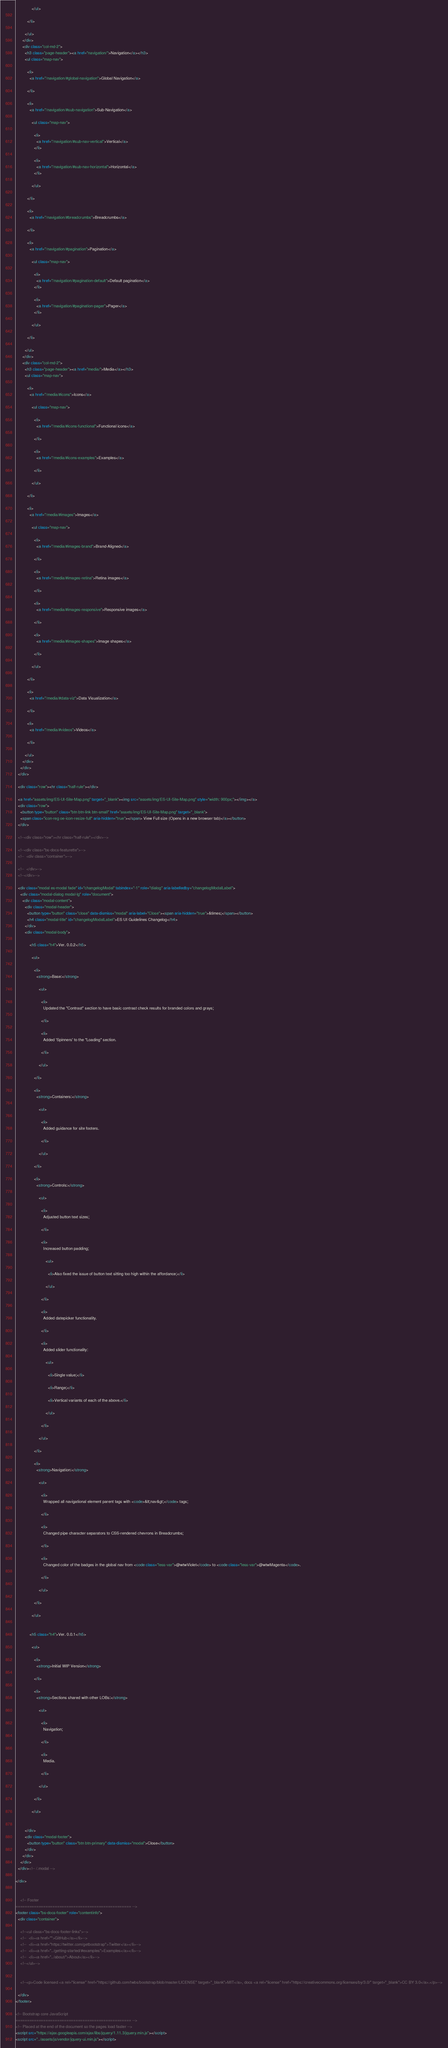<code> <loc_0><loc_0><loc_500><loc_500><_HTML_>              </ul>
            
          </li>
        
        </ul>  
      </div>
      <div class="col-md-2">
        <h3 class="page-header"><a href="navigation/">Navigation</a></h3>
        <ul class="map-nav">
        
          <li>
            <a href="/navigation/#global-navigation">Global Navigation</a>
            
          </li>
        
          <li>
            <a href="/navigation/#sub-navigation">Sub-Navigation</a>
            
              <ul class="map-nav">
                
                <li>
                  <a href="/navigation/#sub-nav-vertical">Vertical</a>
                </li>
                
                <li>
                  <a href="/navigation/#sub-nav-horizontal">Horizontal</a>
                </li>
                
              </ul>
            
          </li>
        
          <li>
            <a href="/navigation/#breadcrumbs">Breadcrumbs</a>
            
          </li>
        
          <li>
            <a href="/navigation/#pagination">Pagination</a>
            
              <ul class="map-nav">
                
                <li>
                  <a href="/navigation/#pagination-default">Default pagination</a>
                </li>
                
                <li>
                  <a href="/navigation/#pagination-pager">Pager</a>
                </li>
                
              </ul>
            
          </li>
        
        </ul>
      </div>
      <div class="col-md-2">
        <h3 class="page-header"><a href="media/">Media</a></h3>
        <ul class="map-nav">
        
          <li>
            <a href="/media/#icons">Icons</a>
            
              <ul class="map-nav">
                
                <li>
                  <a href="/media/#icons-functional">Functional icons</a>
                  
                </li>
                
                <li>
                  <a href="/media/#icons-examples">Examples</a>
                  
                </li>
                
              </ul>
            
          </li>
        
          <li>
            <a href="/media/#images">Images</a>
            
              <ul class="map-nav">
                
                <li>
                  <a href="/media/#images-brand">Brand-Aligned</a>
                  
                </li>
                
                <li>
                  <a href="/media/#images-retina">Retina images</a>
                  
                </li>
                
                <li>
                  <a href="/media/#images-responsive">Responsive images</a>
                  
                </li>
                
                <li>
                  <a href="/media/#images-shapes">Image shapes</a>
                  
                </li>
                
              </ul>
            
          </li>
        
          <li>
            <a href="/media/#data-viz">Data Visualization</a>
            
          </li>
        
          <li>
            <a href="/media/#videos">Videos</a>
            
          </li>
        
        </ul> 
      </div>
    </div>
  </div>
  
  <div class="row"><hr class="half-rule"></div>
  
  <a href="assets/img/ES-UI-Site-Map.png" target="_blank"><img src="assets/img/ES-UI-Site-Map.png" style="width: 900px;"></img></a>
  <div class="row">
    <button type="button" class="btn btn-link btn-small" href="assets/img/ES-UI-Site-Map.png" target="_blank">
    <span class="icon-reg oe-icon-resize-full" aria-hidden="true"></span> View Full size (Opens in a new browser tab)</a></button>
  </div>
  
  <!--<div class="row"><hr class="half-rule"></div>-->
  
  <!--<div class="bs-docs-featurette">-->
  <!--  <div class="container">-->
  
  <!--  </div>-->
  <!--</div>-->
  
  <div class="modal es-modal fade" id="changelogModal" tabindex="-1" role="dialog" aria-labelledby="changelogModalLabel">
    <div class="modal-dialog modal-lg" role="document">
      <div class="modal-content">
        <div class="modal-header">
          <button type="button" class="close" data-dismiss="modal" aria-label="Close"><span aria-hidden="true">&times;</span></button>
          <h4 class="modal-title" id="changelogModalLabel">ES UI Guidelines Changelog</h4>
        </div>
        <div class="modal-body">
          
            <h5 class="h4">Ver. 0.0.2</h5>
            
              <ul>
                
                <li>
                  <strong>Base:</strong>
                  
                    <ul>
                      
                      <li>
                        Updated the "Contrast" section to have basic contrast check results for branded colors and grays;
                        
                      </li>
                      
                      <li>
                        Added 'Spinners' to the "Loading" section.
                        
                      </li>
                      
                    </ul>
                  
                </li>
                
                <li>
                  <strong>Containers:</strong>
                  
                    <ul>
                      
                      <li>
                        Added guidance for site footers.
                        
                      </li>
                      
                    </ul>
                  
                </li>
                
                <li>
                  <strong>Controls:</strong>
                  
                    <ul>
                      
                      <li>
                        Adjusted button text sizes;
                        
                      </li>
                      
                      <li>
                        Increased button padding;
                        
                          <ul>
                            
                            <li>Also fixed the issue of button text sitting too high within the affordance;</li>
                            
                          </ul>
                        
                      </li>
                      
                      <li>
                        Added datepicker functionality.
                        
                      </li>
                      
                      <li>
                        Added slider functionality:
                        
                          <ul>
                            
                            <li>Single value;</li>
                            
                            <li>Range;</li>
                            
                            <li>Vertical variants of each of the above.</li>
                            
                          </ul>
                        
                      </li>
                      
                    </ul>
                  
                </li>
                
                <li>
                  <strong>Navigation:</strong>
                  
                    <ul>
                      
                      <li>
                        Wrapped all navigational element parent tags with <code>&lt;nav&gt;</code> tags;
                        
                      </li>
                      
                      <li>
                        Changed pipe character separators to CSS-rendered chevrons in Breadcrumbs;
                        
                      </li>
                      
                      <li>
                        Changed color of the badges in the global nav from <code class="less-var">@wtwViolet</code> to <code class="less-var">@wtwMagenta</code>.
                        
                      </li>
                      
                    </ul>
                  
                </li>
                
              </ul>
            
          
            <h5 class="h4">Ver. 0.0.1</h5>
            
              <ul>
                
                <li>
                  <strong>Initial WIP Version</strong>
                  
                </li>
                
                <li>
                  <strong>Sections shared with other LOBs:</strong>
                  
                    <ul>
                      
                      <li>
                        Navigation;
                        
                      </li>
                      
                      <li>
                        Media.
                        
                      </li>
                      
                    </ul>
                  
                </li>
                
              </ul>
            
          
        </div>
        <div class="modal-footer">
          <button type="button" class="btn btn-primary" data-dismiss="modal">Close</button>
        </div>
      </div>
    </div>
  </div><!-- /.modal -->
  
</div>


    <!-- Footer
================================================== -->
<footer class="bs-docs-footer" role="contentinfo">
  <div class="container">

    <!--<ul class="bs-docs-footer-links">-->
    <!--  <li><a href="">GitHub</a></li>-->
    <!--  <li><a href="https://twitter.com/getbootstrap">Twitter</a></li>-->
    <!--  <li><a href="../getting-started/#examples">Examples</a></li>-->
    <!--  <li><a href="../about/">About</a></li>-->
    <!--</ul>-->


    <!--<p>Code licensed <a rel="license" href="https://github.com/twbs/bootstrap/blob/master/LICENSE" target="_blank">MIT</a>, docs <a rel="license" href="https://creativecommons.org/licenses/by/3.0/" target="_blank">CC BY 3.0</a>.</p>-->

  </div>
</footer>

<!-- Bootstrap core JavaScript
================================================== -->
<!-- Placed at the end of the document so the pages load faster -->
<script src="https://ajax.googleapis.com/ajax/libs/jquery/1.11.3/jquery.min.js"></script>
<script src="../assets/js/vendor/jquery-ui.min.js"></script></code> 